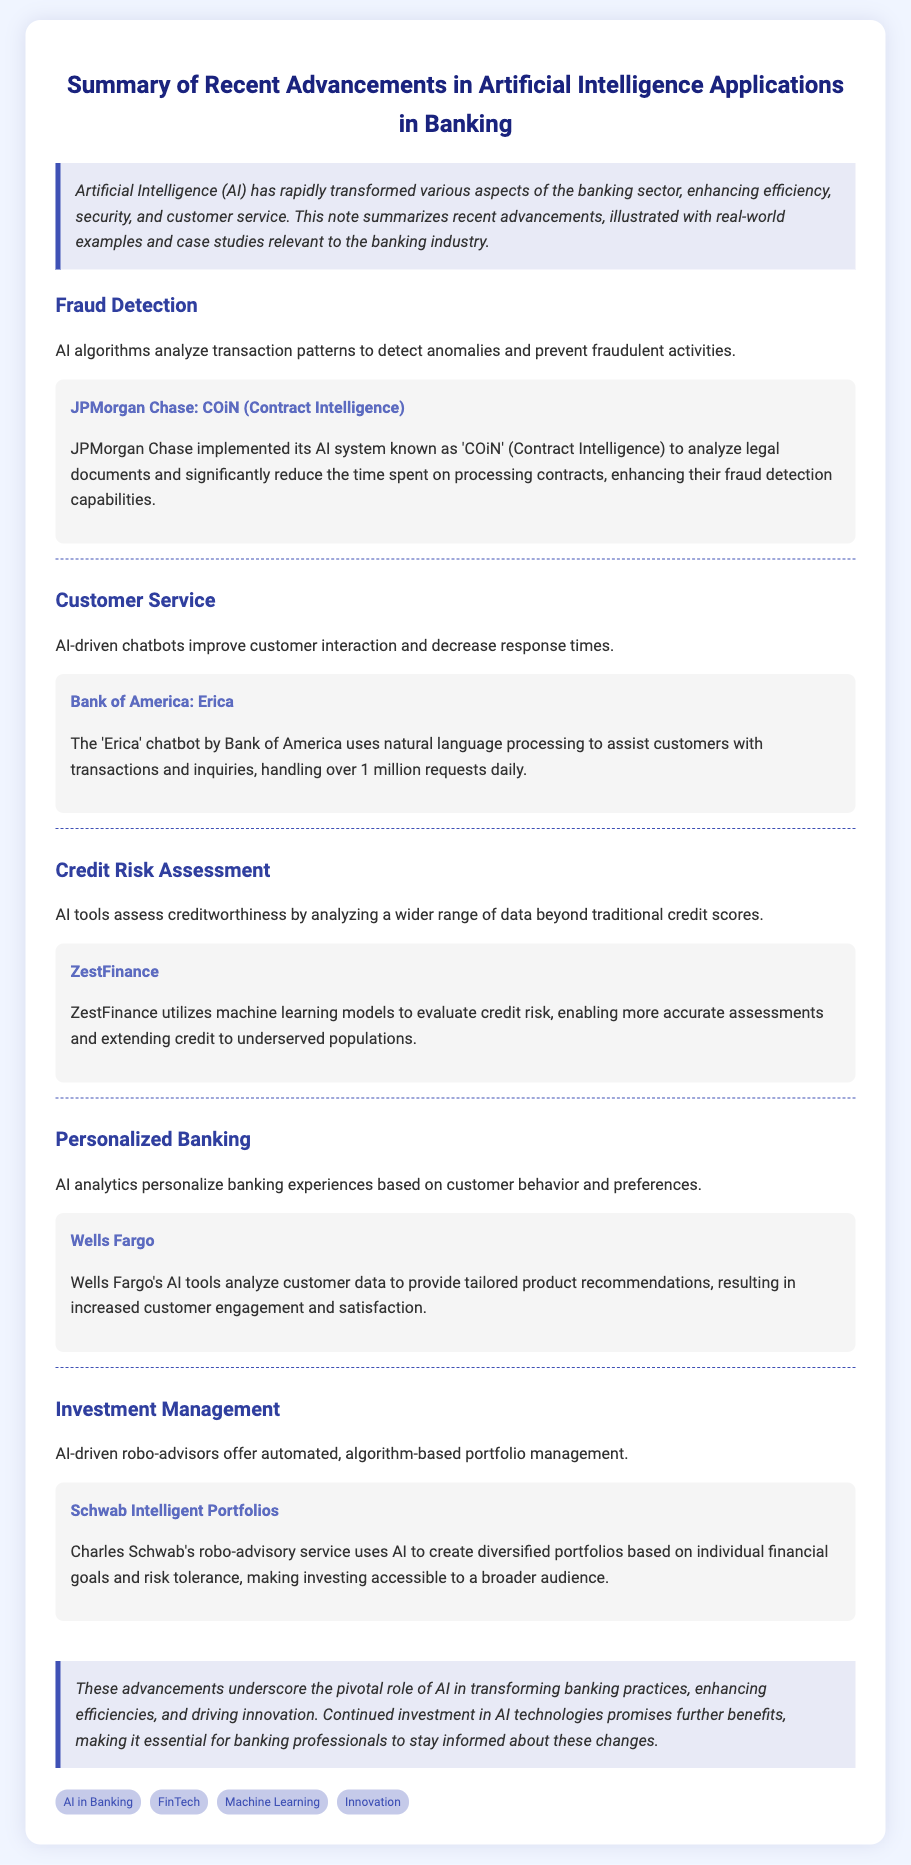What is the title of the document? The title is indicated at the top of the document as the main heading.
Answer: Summary of Recent Advancements in Artificial Intelligence Applications in Banking Who implemented the COiN system? The document mentions JPMorgan Chase as the institution that implemented the COiN system for contract analysis.
Answer: JPMorgan Chase What does the 'Erica' chatbot assist with? The document states that Erica assists customers with transactions and inquiries.
Answer: Transactions and inquiries Which company utilizes machine learning for credit risk assessment? The document specifically names ZestFinance as the company using machine learning models for this purpose.
Answer: ZestFinance How many requests does the 'Erica' chatbot handle daily? The text indicates that Erica handles over 1 million requests on a daily basis.
Answer: Over 1 million What type of service is provided by Schwab Intelligent Portfolios? According to the document, Schwab Intelligent Portfolios offers robo-advisory services for investment management.
Answer: Robo-advisory services Which bank's AI tools provide tailored product recommendations? The document states that Wells Fargo's AI tools analyze customer data for product recommendations.
Answer: Wells Fargo What is the primary focus of AI in banking, according to the conclusion? The conclusion summarizes the role of AI in transforming banking practices and enhancing efficiencies.
Answer: Transforming banking practices What advancements are highlighted in the document? The document highlights areas such as fraud detection, customer service, credit risk assessment, personalized banking, and investment management.
Answer: Fraud detection, customer service, credit risk assessment, personalized banking, investment management 